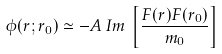<formula> <loc_0><loc_0><loc_500><loc_500>\phi ( r ; r _ { 0 } ) \simeq - A \, I m \, \left [ \frac { F ( r ) F ( r _ { 0 } ) } { m _ { 0 } } \right ]</formula> 